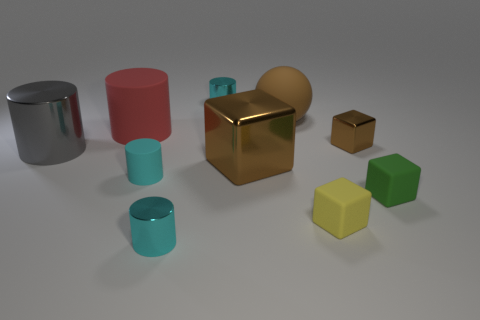Subtract all large shiny cylinders. How many cylinders are left? 4 Subtract all brown spheres. How many cyan cylinders are left? 3 Subtract 1 blocks. How many blocks are left? 3 Subtract all gray cylinders. How many cylinders are left? 4 Subtract all gray blocks. Subtract all gray balls. How many blocks are left? 4 Subtract all cubes. How many objects are left? 6 Subtract all gray cylinders. Subtract all big red rubber cylinders. How many objects are left? 8 Add 2 yellow rubber objects. How many yellow rubber objects are left? 3 Add 2 red matte cylinders. How many red matte cylinders exist? 3 Subtract 0 blue cylinders. How many objects are left? 10 